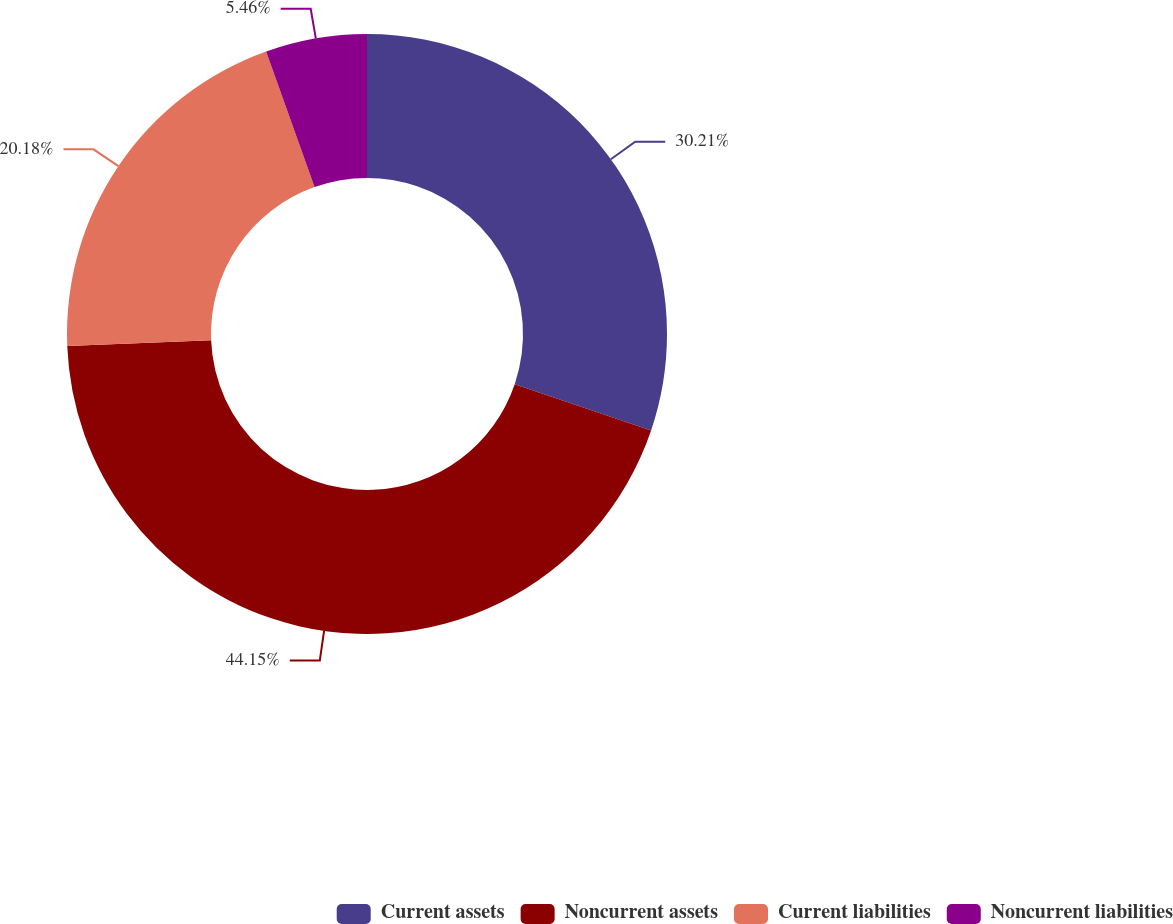Convert chart to OTSL. <chart><loc_0><loc_0><loc_500><loc_500><pie_chart><fcel>Current assets<fcel>Noncurrent assets<fcel>Current liabilities<fcel>Noncurrent liabilities<nl><fcel>30.21%<fcel>44.16%<fcel>20.18%<fcel>5.46%<nl></chart> 